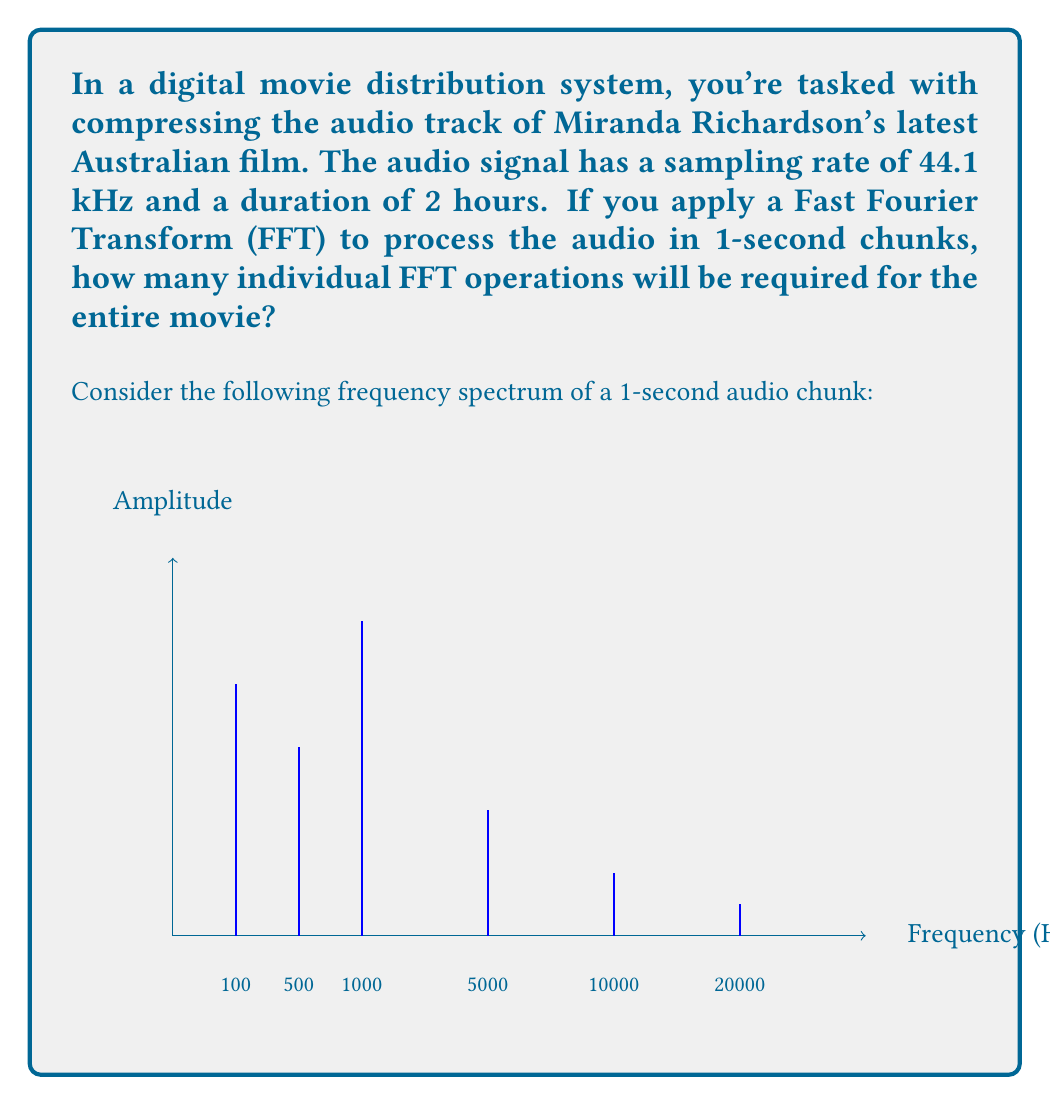Teach me how to tackle this problem. Let's approach this step-by-step:

1) First, we need to calculate the total number of seconds in the movie:
   $$ 2 \text{ hours} = 2 \times 60 \times 60 = 7200 \text{ seconds} $$

2) The question states that we're processing the audio in 1-second chunks. This means we'll need to perform one FFT operation for each second of the movie.

3) The number of FFT operations is therefore equal to the number of seconds:
   $$ \text{Number of FFT operations} = 7200 $$

4) It's worth noting that for each 1-second chunk:
   - We have 44.1 kHz sampling rate, meaning 44,100 samples per second
   - The FFT size would typically be the next power of 2, which is 65,536 (2^16)
   - The frequency resolution would be 44100/65536 ≈ 0.67 Hz
   - The maximum frequency represented would be 22.05 kHz (Nyquist frequency)

5) The frequency spectrum shown in the question illustrates how the FFT would break down the audio into its component frequencies, allowing for more efficient compression by prioritizing the most significant frequencies.

6) In practice, the compression algorithm would use this spectral information to allocate more bits to the frequencies with higher amplitudes (like the peak at 1000 Hz in the diagram) and fewer bits to the less significant frequencies, thus reducing the overall data size while preserving audio quality.
Answer: 7200 FFT operations 